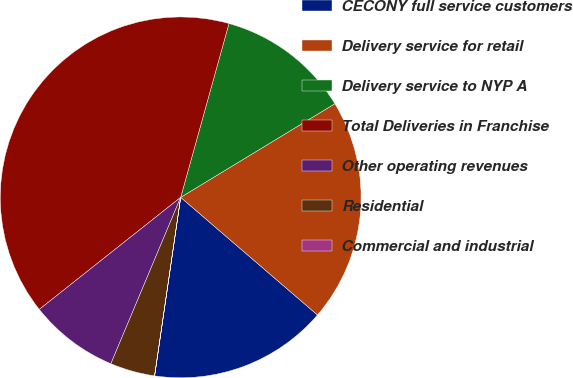<chart> <loc_0><loc_0><loc_500><loc_500><pie_chart><fcel>CECONY full service customers<fcel>Delivery service for retail<fcel>Delivery service to NYP A<fcel>Total Deliveries in Franchise<fcel>Other operating revenues<fcel>Residential<fcel>Commercial and industrial<nl><fcel>16.0%<fcel>19.99%<fcel>12.0%<fcel>39.98%<fcel>8.01%<fcel>4.01%<fcel>0.01%<nl></chart> 